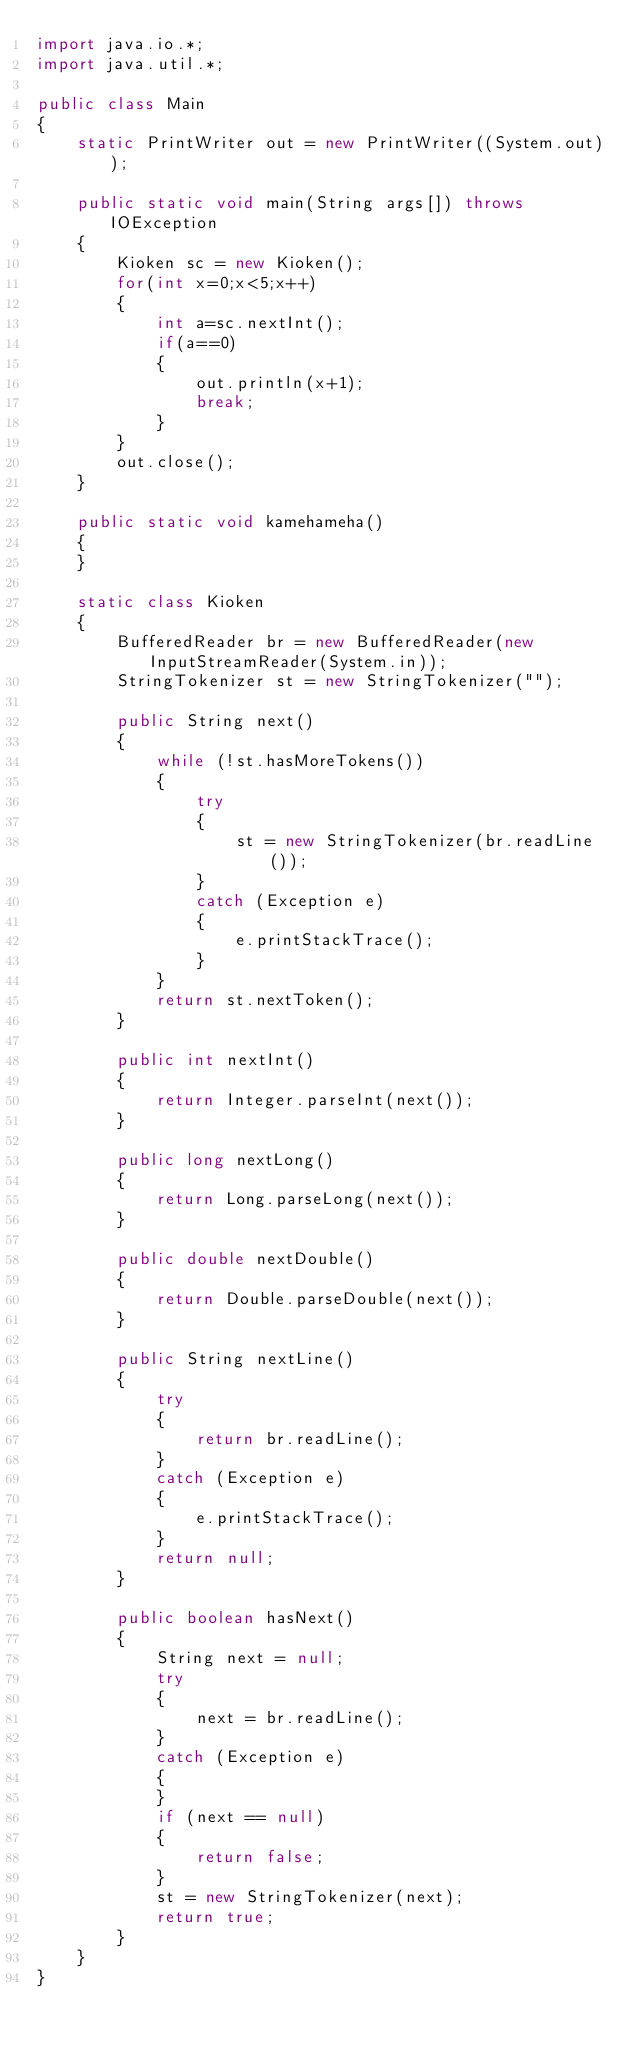Convert code to text. <code><loc_0><loc_0><loc_500><loc_500><_Java_>import java.io.*;
import java.util.*;

public class Main
{
    static PrintWriter out = new PrintWriter((System.out));

    public static void main(String args[]) throws IOException
    {
        Kioken sc = new Kioken();
        for(int x=0;x<5;x++)
        {
            int a=sc.nextInt();
            if(a==0)
            {
                out.println(x+1);
                break;
            }
        }
        out.close();
    }

    public static void kamehameha()
    {
    }

    static class Kioken
    {
        BufferedReader br = new BufferedReader(new InputStreamReader(System.in));
        StringTokenizer st = new StringTokenizer("");

        public String next()
        {
            while (!st.hasMoreTokens())
            {
                try
                {
                    st = new StringTokenizer(br.readLine());
                }
                catch (Exception e)
                {
                    e.printStackTrace();
                }
            }
            return st.nextToken();
        }

        public int nextInt()
        {
            return Integer.parseInt(next());
        }

        public long nextLong()
        {
            return Long.parseLong(next());
        }

        public double nextDouble()
        {
            return Double.parseDouble(next());
        }

        public String nextLine()
        {
            try
            {
                return br.readLine();
            }
            catch (Exception e)
            {
                e.printStackTrace();
            }
            return null;
        }

        public boolean hasNext()
        {
            String next = null;
            try
            {
                next = br.readLine();
            }
            catch (Exception e)
            {
            }
            if (next == null)
            {
                return false;
            }
            st = new StringTokenizer(next);
            return true;
        }
    }
}</code> 